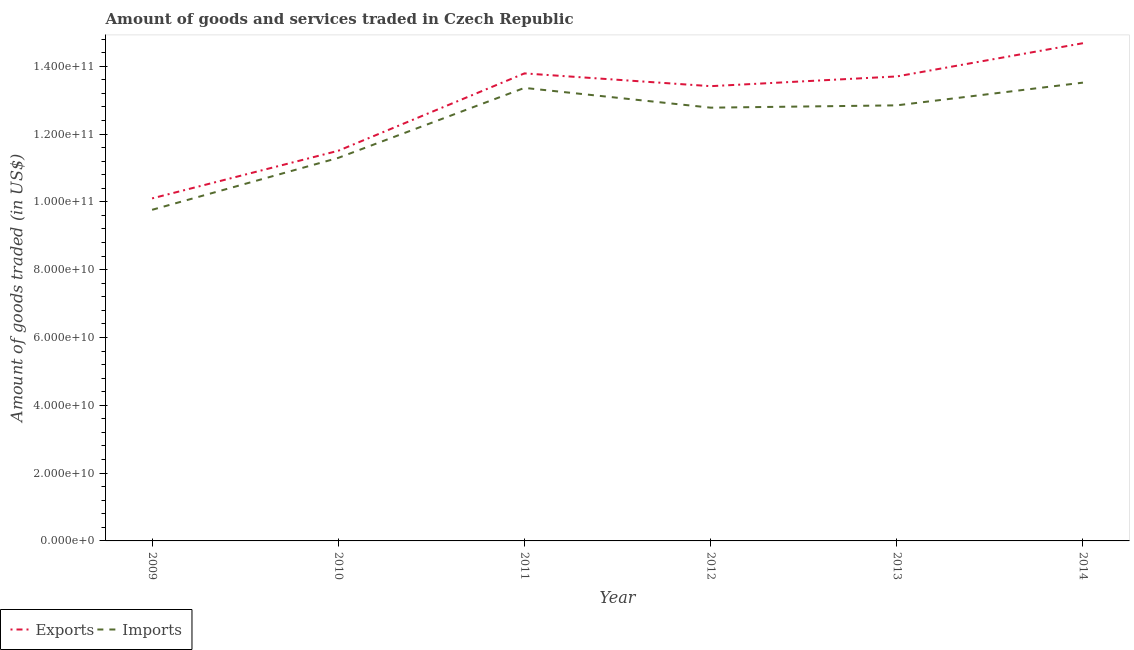What is the amount of goods exported in 2014?
Provide a short and direct response. 1.47e+11. Across all years, what is the maximum amount of goods exported?
Keep it short and to the point. 1.47e+11. Across all years, what is the minimum amount of goods exported?
Your response must be concise. 1.01e+11. What is the total amount of goods imported in the graph?
Ensure brevity in your answer.  7.36e+11. What is the difference between the amount of goods imported in 2010 and that in 2013?
Offer a very short reply. -1.55e+1. What is the difference between the amount of goods imported in 2013 and the amount of goods exported in 2009?
Provide a short and direct response. 2.74e+1. What is the average amount of goods exported per year?
Ensure brevity in your answer.  1.29e+11. In the year 2010, what is the difference between the amount of goods imported and amount of goods exported?
Your answer should be very brief. -2.10e+09. In how many years, is the amount of goods exported greater than 72000000000 US$?
Your answer should be compact. 6. What is the ratio of the amount of goods imported in 2009 to that in 2013?
Keep it short and to the point. 0.76. Is the amount of goods imported in 2012 less than that in 2013?
Make the answer very short. Yes. What is the difference between the highest and the second highest amount of goods imported?
Keep it short and to the point. 1.55e+09. What is the difference between the highest and the lowest amount of goods exported?
Your answer should be compact. 4.58e+1. In how many years, is the amount of goods exported greater than the average amount of goods exported taken over all years?
Provide a succinct answer. 4. Does the amount of goods exported monotonically increase over the years?
Ensure brevity in your answer.  No. Is the amount of goods imported strictly less than the amount of goods exported over the years?
Your answer should be very brief. Yes. How many lines are there?
Your answer should be very brief. 2. Does the graph contain any zero values?
Keep it short and to the point. No. Does the graph contain grids?
Give a very brief answer. No. How many legend labels are there?
Ensure brevity in your answer.  2. How are the legend labels stacked?
Give a very brief answer. Horizontal. What is the title of the graph?
Your answer should be very brief. Amount of goods and services traded in Czech Republic. What is the label or title of the X-axis?
Provide a short and direct response. Year. What is the label or title of the Y-axis?
Ensure brevity in your answer.  Amount of goods traded (in US$). What is the Amount of goods traded (in US$) of Exports in 2009?
Ensure brevity in your answer.  1.01e+11. What is the Amount of goods traded (in US$) of Imports in 2009?
Offer a terse response. 9.77e+1. What is the Amount of goods traded (in US$) of Exports in 2010?
Make the answer very short. 1.15e+11. What is the Amount of goods traded (in US$) of Imports in 2010?
Offer a terse response. 1.13e+11. What is the Amount of goods traded (in US$) in Exports in 2011?
Your response must be concise. 1.38e+11. What is the Amount of goods traded (in US$) of Imports in 2011?
Your response must be concise. 1.34e+11. What is the Amount of goods traded (in US$) of Exports in 2012?
Ensure brevity in your answer.  1.34e+11. What is the Amount of goods traded (in US$) in Imports in 2012?
Your response must be concise. 1.28e+11. What is the Amount of goods traded (in US$) in Exports in 2013?
Your response must be concise. 1.37e+11. What is the Amount of goods traded (in US$) in Imports in 2013?
Make the answer very short. 1.28e+11. What is the Amount of goods traded (in US$) in Exports in 2014?
Give a very brief answer. 1.47e+11. What is the Amount of goods traded (in US$) in Imports in 2014?
Keep it short and to the point. 1.35e+11. Across all years, what is the maximum Amount of goods traded (in US$) in Exports?
Offer a very short reply. 1.47e+11. Across all years, what is the maximum Amount of goods traded (in US$) of Imports?
Offer a terse response. 1.35e+11. Across all years, what is the minimum Amount of goods traded (in US$) in Exports?
Offer a very short reply. 1.01e+11. Across all years, what is the minimum Amount of goods traded (in US$) of Imports?
Offer a very short reply. 9.77e+1. What is the total Amount of goods traded (in US$) in Exports in the graph?
Offer a terse response. 7.72e+11. What is the total Amount of goods traded (in US$) of Imports in the graph?
Make the answer very short. 7.36e+11. What is the difference between the Amount of goods traded (in US$) of Exports in 2009 and that in 2010?
Keep it short and to the point. -1.40e+1. What is the difference between the Amount of goods traded (in US$) of Imports in 2009 and that in 2010?
Offer a terse response. -1.53e+1. What is the difference between the Amount of goods traded (in US$) in Exports in 2009 and that in 2011?
Provide a succinct answer. -3.69e+1. What is the difference between the Amount of goods traded (in US$) in Imports in 2009 and that in 2011?
Make the answer very short. -3.60e+1. What is the difference between the Amount of goods traded (in US$) of Exports in 2009 and that in 2012?
Your response must be concise. -3.31e+1. What is the difference between the Amount of goods traded (in US$) of Imports in 2009 and that in 2012?
Keep it short and to the point. -3.01e+1. What is the difference between the Amount of goods traded (in US$) of Exports in 2009 and that in 2013?
Give a very brief answer. -3.60e+1. What is the difference between the Amount of goods traded (in US$) in Imports in 2009 and that in 2013?
Make the answer very short. -3.08e+1. What is the difference between the Amount of goods traded (in US$) of Exports in 2009 and that in 2014?
Your response must be concise. -4.58e+1. What is the difference between the Amount of goods traded (in US$) of Imports in 2009 and that in 2014?
Offer a very short reply. -3.75e+1. What is the difference between the Amount of goods traded (in US$) of Exports in 2010 and that in 2011?
Your answer should be very brief. -2.28e+1. What is the difference between the Amount of goods traded (in US$) of Imports in 2010 and that in 2011?
Make the answer very short. -2.06e+1. What is the difference between the Amount of goods traded (in US$) in Exports in 2010 and that in 2012?
Your answer should be very brief. -1.91e+1. What is the difference between the Amount of goods traded (in US$) of Imports in 2010 and that in 2012?
Give a very brief answer. -1.48e+1. What is the difference between the Amount of goods traded (in US$) in Exports in 2010 and that in 2013?
Offer a very short reply. -2.19e+1. What is the difference between the Amount of goods traded (in US$) of Imports in 2010 and that in 2013?
Give a very brief answer. -1.55e+1. What is the difference between the Amount of goods traded (in US$) of Exports in 2010 and that in 2014?
Provide a short and direct response. -3.17e+1. What is the difference between the Amount of goods traded (in US$) of Imports in 2010 and that in 2014?
Your answer should be compact. -2.22e+1. What is the difference between the Amount of goods traded (in US$) of Exports in 2011 and that in 2012?
Your answer should be very brief. 3.77e+09. What is the difference between the Amount of goods traded (in US$) of Imports in 2011 and that in 2012?
Your response must be concise. 5.83e+09. What is the difference between the Amount of goods traded (in US$) in Exports in 2011 and that in 2013?
Keep it short and to the point. 8.98e+08. What is the difference between the Amount of goods traded (in US$) of Imports in 2011 and that in 2013?
Provide a short and direct response. 5.15e+09. What is the difference between the Amount of goods traded (in US$) in Exports in 2011 and that in 2014?
Give a very brief answer. -8.90e+09. What is the difference between the Amount of goods traded (in US$) in Imports in 2011 and that in 2014?
Give a very brief answer. -1.55e+09. What is the difference between the Amount of goods traded (in US$) in Exports in 2012 and that in 2013?
Provide a short and direct response. -2.87e+09. What is the difference between the Amount of goods traded (in US$) of Imports in 2012 and that in 2013?
Make the answer very short. -6.83e+08. What is the difference between the Amount of goods traded (in US$) in Exports in 2012 and that in 2014?
Give a very brief answer. -1.27e+1. What is the difference between the Amount of goods traded (in US$) in Imports in 2012 and that in 2014?
Keep it short and to the point. -7.38e+09. What is the difference between the Amount of goods traded (in US$) in Exports in 2013 and that in 2014?
Your answer should be very brief. -9.80e+09. What is the difference between the Amount of goods traded (in US$) of Imports in 2013 and that in 2014?
Make the answer very short. -6.70e+09. What is the difference between the Amount of goods traded (in US$) of Exports in 2009 and the Amount of goods traded (in US$) of Imports in 2010?
Give a very brief answer. -1.19e+1. What is the difference between the Amount of goods traded (in US$) in Exports in 2009 and the Amount of goods traded (in US$) in Imports in 2011?
Provide a succinct answer. -3.26e+1. What is the difference between the Amount of goods traded (in US$) in Exports in 2009 and the Amount of goods traded (in US$) in Imports in 2012?
Your response must be concise. -2.68e+1. What is the difference between the Amount of goods traded (in US$) in Exports in 2009 and the Amount of goods traded (in US$) in Imports in 2013?
Make the answer very short. -2.74e+1. What is the difference between the Amount of goods traded (in US$) of Exports in 2009 and the Amount of goods traded (in US$) of Imports in 2014?
Offer a terse response. -3.41e+1. What is the difference between the Amount of goods traded (in US$) of Exports in 2010 and the Amount of goods traded (in US$) of Imports in 2011?
Give a very brief answer. -1.85e+1. What is the difference between the Amount of goods traded (in US$) of Exports in 2010 and the Amount of goods traded (in US$) of Imports in 2012?
Provide a succinct answer. -1.27e+1. What is the difference between the Amount of goods traded (in US$) in Exports in 2010 and the Amount of goods traded (in US$) in Imports in 2013?
Offer a terse response. -1.34e+1. What is the difference between the Amount of goods traded (in US$) of Exports in 2010 and the Amount of goods traded (in US$) of Imports in 2014?
Your response must be concise. -2.01e+1. What is the difference between the Amount of goods traded (in US$) of Exports in 2011 and the Amount of goods traded (in US$) of Imports in 2012?
Provide a succinct answer. 1.01e+1. What is the difference between the Amount of goods traded (in US$) of Exports in 2011 and the Amount of goods traded (in US$) of Imports in 2013?
Provide a short and direct response. 9.42e+09. What is the difference between the Amount of goods traded (in US$) in Exports in 2011 and the Amount of goods traded (in US$) in Imports in 2014?
Your answer should be compact. 2.72e+09. What is the difference between the Amount of goods traded (in US$) of Exports in 2012 and the Amount of goods traded (in US$) of Imports in 2013?
Give a very brief answer. 5.66e+09. What is the difference between the Amount of goods traded (in US$) of Exports in 2012 and the Amount of goods traded (in US$) of Imports in 2014?
Provide a succinct answer. -1.04e+09. What is the difference between the Amount of goods traded (in US$) in Exports in 2013 and the Amount of goods traded (in US$) in Imports in 2014?
Offer a very short reply. 1.83e+09. What is the average Amount of goods traded (in US$) of Exports per year?
Ensure brevity in your answer.  1.29e+11. What is the average Amount of goods traded (in US$) of Imports per year?
Provide a short and direct response. 1.23e+11. In the year 2009, what is the difference between the Amount of goods traded (in US$) of Exports and Amount of goods traded (in US$) of Imports?
Make the answer very short. 3.37e+09. In the year 2010, what is the difference between the Amount of goods traded (in US$) of Exports and Amount of goods traded (in US$) of Imports?
Offer a terse response. 2.10e+09. In the year 2011, what is the difference between the Amount of goods traded (in US$) in Exports and Amount of goods traded (in US$) in Imports?
Ensure brevity in your answer.  4.28e+09. In the year 2012, what is the difference between the Amount of goods traded (in US$) of Exports and Amount of goods traded (in US$) of Imports?
Your answer should be compact. 6.34e+09. In the year 2013, what is the difference between the Amount of goods traded (in US$) in Exports and Amount of goods traded (in US$) in Imports?
Your answer should be compact. 8.53e+09. In the year 2014, what is the difference between the Amount of goods traded (in US$) of Exports and Amount of goods traded (in US$) of Imports?
Provide a succinct answer. 1.16e+1. What is the ratio of the Amount of goods traded (in US$) of Exports in 2009 to that in 2010?
Offer a very short reply. 0.88. What is the ratio of the Amount of goods traded (in US$) of Imports in 2009 to that in 2010?
Provide a succinct answer. 0.86. What is the ratio of the Amount of goods traded (in US$) of Exports in 2009 to that in 2011?
Provide a short and direct response. 0.73. What is the ratio of the Amount of goods traded (in US$) of Imports in 2009 to that in 2011?
Ensure brevity in your answer.  0.73. What is the ratio of the Amount of goods traded (in US$) in Exports in 2009 to that in 2012?
Make the answer very short. 0.75. What is the ratio of the Amount of goods traded (in US$) of Imports in 2009 to that in 2012?
Keep it short and to the point. 0.76. What is the ratio of the Amount of goods traded (in US$) of Exports in 2009 to that in 2013?
Give a very brief answer. 0.74. What is the ratio of the Amount of goods traded (in US$) of Imports in 2009 to that in 2013?
Provide a short and direct response. 0.76. What is the ratio of the Amount of goods traded (in US$) of Exports in 2009 to that in 2014?
Make the answer very short. 0.69. What is the ratio of the Amount of goods traded (in US$) of Imports in 2009 to that in 2014?
Your response must be concise. 0.72. What is the ratio of the Amount of goods traded (in US$) in Exports in 2010 to that in 2011?
Offer a terse response. 0.83. What is the ratio of the Amount of goods traded (in US$) of Imports in 2010 to that in 2011?
Provide a short and direct response. 0.85. What is the ratio of the Amount of goods traded (in US$) of Exports in 2010 to that in 2012?
Keep it short and to the point. 0.86. What is the ratio of the Amount of goods traded (in US$) of Imports in 2010 to that in 2012?
Your answer should be compact. 0.88. What is the ratio of the Amount of goods traded (in US$) of Exports in 2010 to that in 2013?
Provide a succinct answer. 0.84. What is the ratio of the Amount of goods traded (in US$) of Imports in 2010 to that in 2013?
Ensure brevity in your answer.  0.88. What is the ratio of the Amount of goods traded (in US$) in Exports in 2010 to that in 2014?
Provide a succinct answer. 0.78. What is the ratio of the Amount of goods traded (in US$) of Imports in 2010 to that in 2014?
Offer a terse response. 0.84. What is the ratio of the Amount of goods traded (in US$) in Exports in 2011 to that in 2012?
Provide a succinct answer. 1.03. What is the ratio of the Amount of goods traded (in US$) in Imports in 2011 to that in 2012?
Ensure brevity in your answer.  1.05. What is the ratio of the Amount of goods traded (in US$) of Exports in 2011 to that in 2013?
Ensure brevity in your answer.  1.01. What is the ratio of the Amount of goods traded (in US$) in Imports in 2011 to that in 2013?
Give a very brief answer. 1.04. What is the ratio of the Amount of goods traded (in US$) of Exports in 2011 to that in 2014?
Your response must be concise. 0.94. What is the ratio of the Amount of goods traded (in US$) of Exports in 2012 to that in 2013?
Ensure brevity in your answer.  0.98. What is the ratio of the Amount of goods traded (in US$) of Exports in 2012 to that in 2014?
Your response must be concise. 0.91. What is the ratio of the Amount of goods traded (in US$) of Imports in 2012 to that in 2014?
Offer a very short reply. 0.95. What is the ratio of the Amount of goods traded (in US$) in Exports in 2013 to that in 2014?
Give a very brief answer. 0.93. What is the ratio of the Amount of goods traded (in US$) of Imports in 2013 to that in 2014?
Your answer should be very brief. 0.95. What is the difference between the highest and the second highest Amount of goods traded (in US$) of Exports?
Provide a short and direct response. 8.90e+09. What is the difference between the highest and the second highest Amount of goods traded (in US$) in Imports?
Give a very brief answer. 1.55e+09. What is the difference between the highest and the lowest Amount of goods traded (in US$) in Exports?
Make the answer very short. 4.58e+1. What is the difference between the highest and the lowest Amount of goods traded (in US$) in Imports?
Offer a terse response. 3.75e+1. 